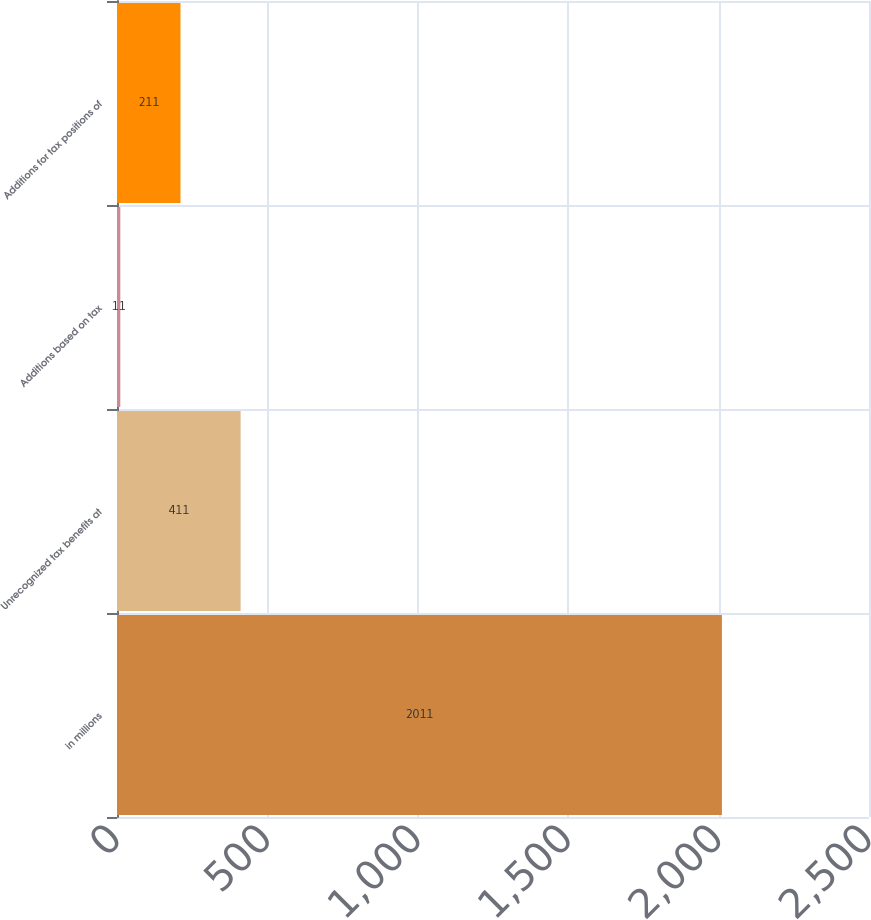Convert chart. <chart><loc_0><loc_0><loc_500><loc_500><bar_chart><fcel>in millions<fcel>Unrecognized tax benefits at<fcel>Additions based on tax<fcel>Additions for tax positions of<nl><fcel>2011<fcel>411<fcel>11<fcel>211<nl></chart> 